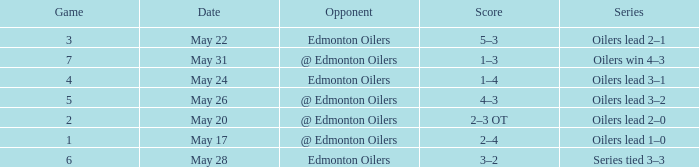Chain of oilers success 4-3 experienced which paramount game? 7.0. 